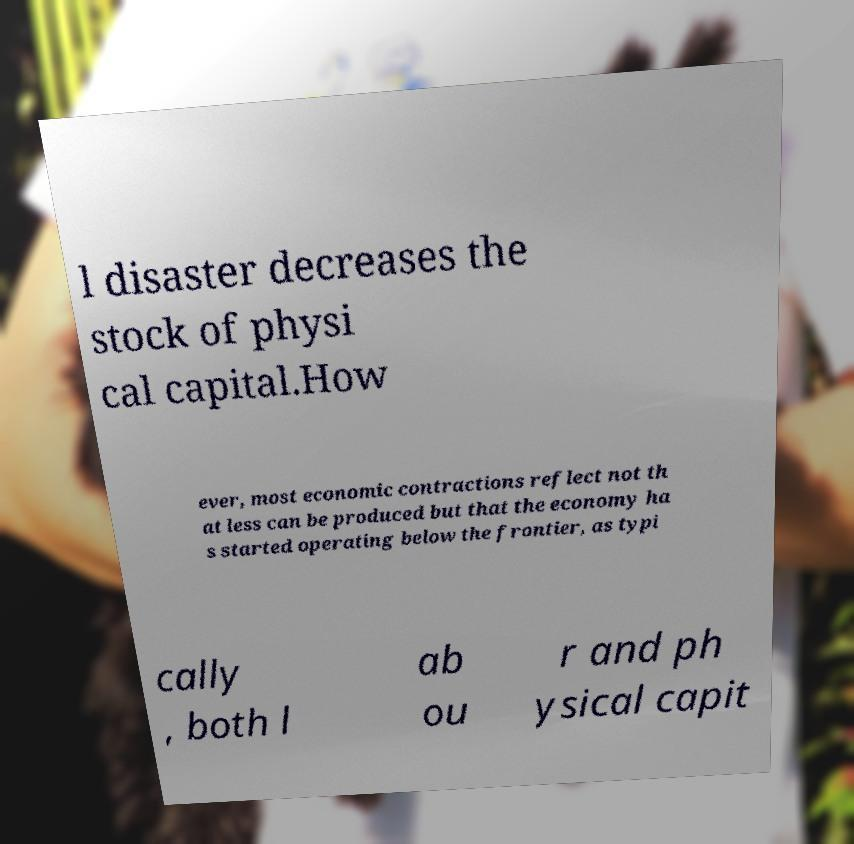Please identify and transcribe the text found in this image. l disaster decreases the stock of physi cal capital.How ever, most economic contractions reflect not th at less can be produced but that the economy ha s started operating below the frontier, as typi cally , both l ab ou r and ph ysical capit 